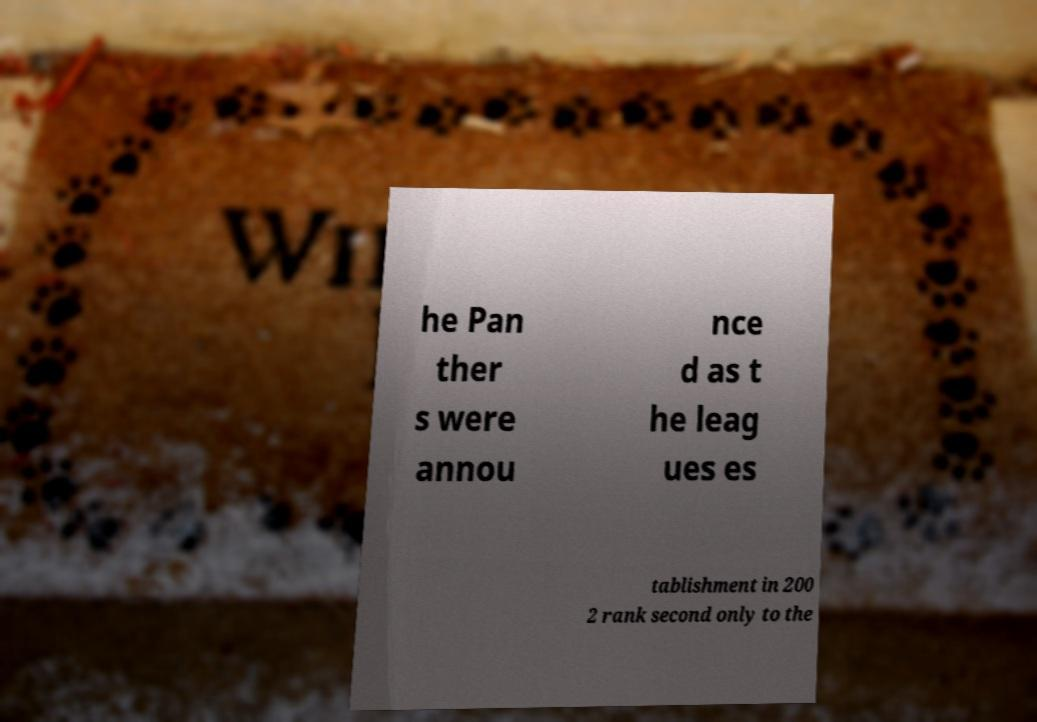Can you accurately transcribe the text from the provided image for me? he Pan ther s were annou nce d as t he leag ues es tablishment in 200 2 rank second only to the 